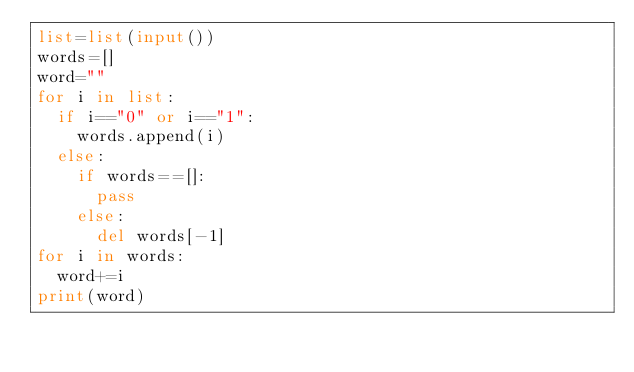<code> <loc_0><loc_0><loc_500><loc_500><_Python_>list=list(input())
words=[]
word=""
for i in list:
  if i=="0" or i=="1":
    words.append(i)
  else:
    if words==[]:
      pass
    else:
      del words[-1]
for i in words:
  word+=i
print(word)</code> 